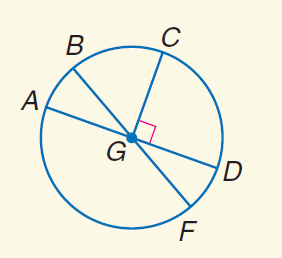Answer the mathemtical geometry problem and directly provide the correct option letter.
Question: In \odot G, m \angle A G B = 30 and C G \perp G D. Find m \widehat B C D.
Choices: A: 30 B: 45 C: 120 D: 150 D 